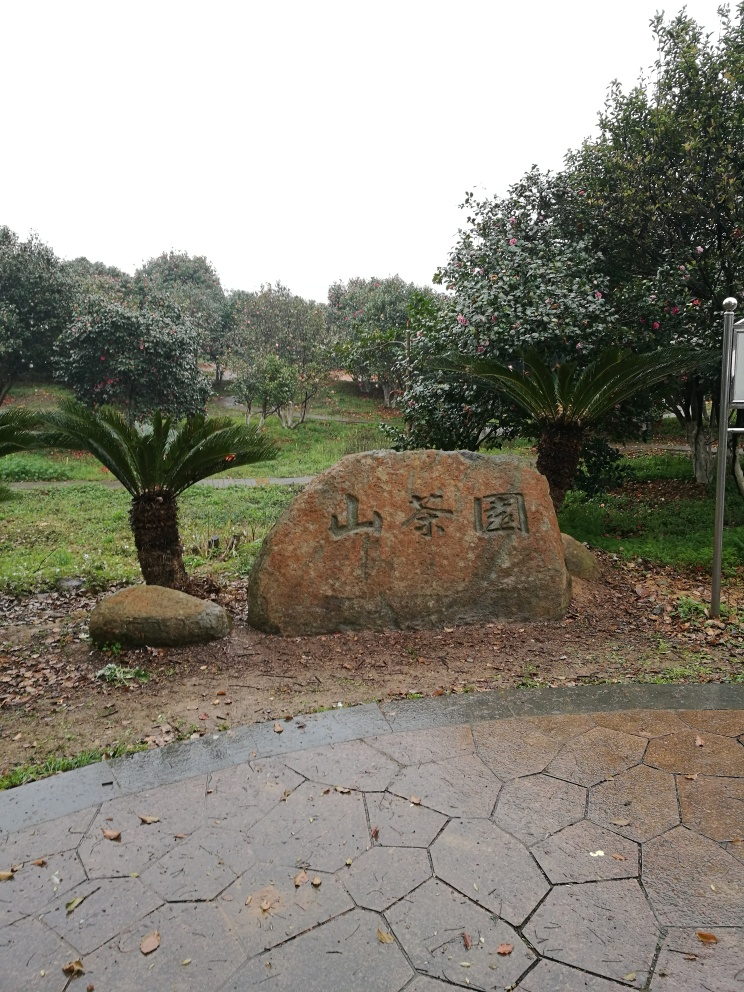Describe the setting around the stone. The stone is set within a tranquil garden scene, surrounded by an array of trees and shrubbery. The vegetation looks lush, indicating that the garden is well-maintained. A paved pathway in the foreground leads towards the stone, inviting viewers to approach and perhaps read the inscription. It looks very peaceful; what might be the purpose of this garden? Such gardens are often designed as spaces for relaxation, reflection, and appreciation of natural beauty. It could be a public park or a part of a cultural heritage site, aimed at providing visitors with a serene environment. 